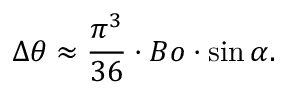Convert formula to latex. <formula><loc_0><loc_0><loc_500><loc_500>\Delta \theta \approx \frac { \pi ^ { 3 } } { 3 6 } \cdot B o \cdot \sin \alpha .</formula> 